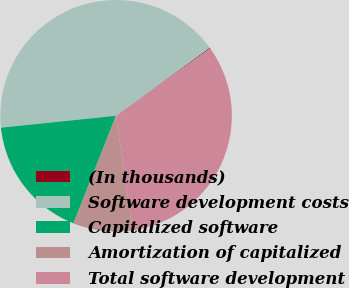<chart> <loc_0><loc_0><loc_500><loc_500><pie_chart><fcel>(In thousands)<fcel>Software development costs<fcel>Capitalized software<fcel>Amortization of capitalized<fcel>Total software development<nl><fcel>0.12%<fcel>41.65%<fcel>17.36%<fcel>8.29%<fcel>32.59%<nl></chart> 